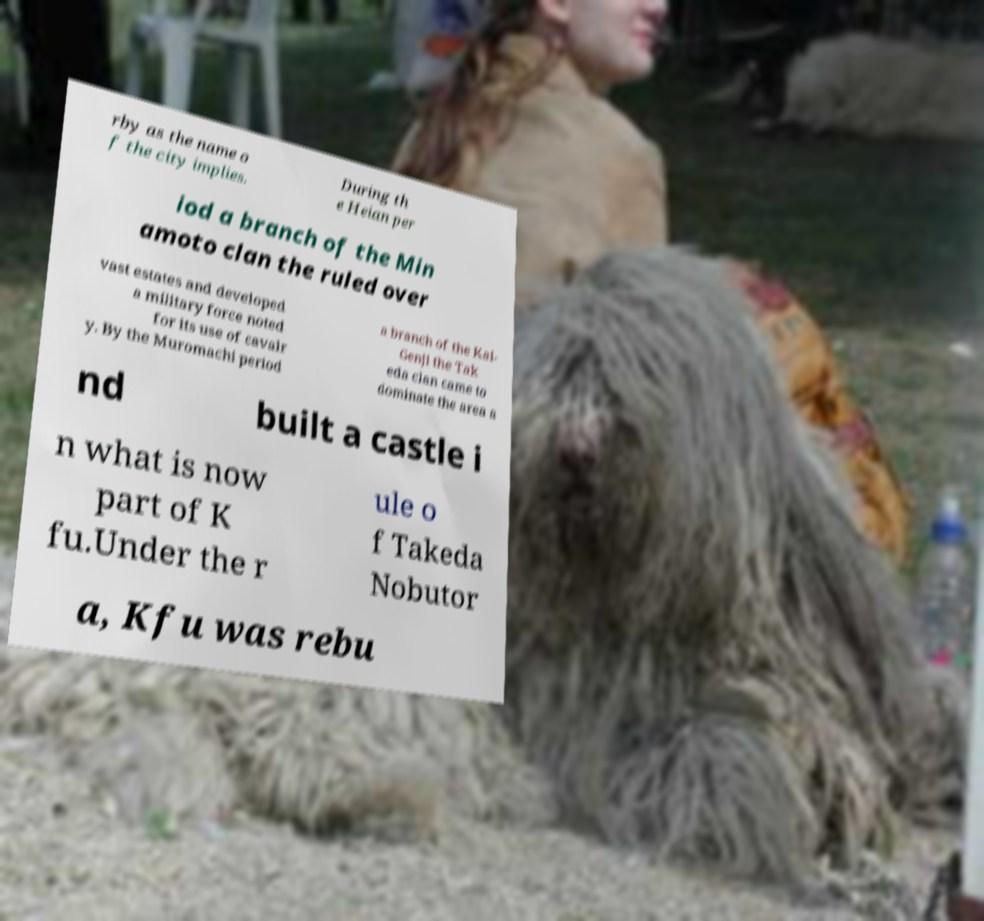There's text embedded in this image that I need extracted. Can you transcribe it verbatim? rby as the name o f the city implies. During th e Heian per iod a branch of the Min amoto clan the ruled over vast estates and developed a military force noted for its use of cavalr y. By the Muromachi period a branch of the Kai- Genji the Tak eda clan came to dominate the area a nd built a castle i n what is now part of K fu.Under the r ule o f Takeda Nobutor a, Kfu was rebu 